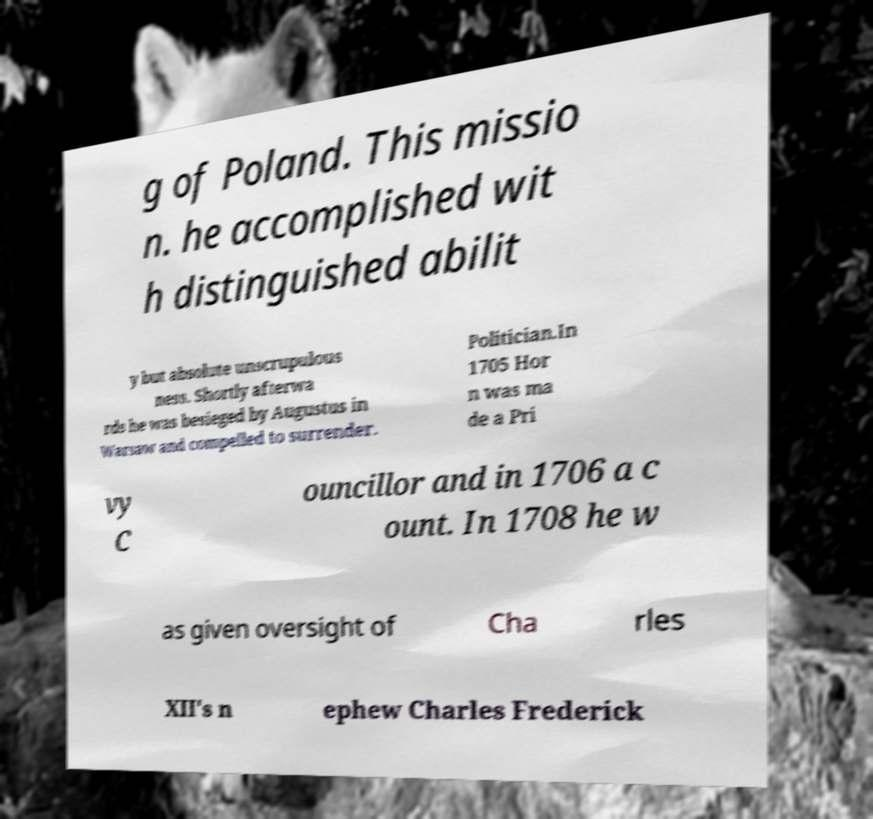Please identify and transcribe the text found in this image. g of Poland. This missio n. he accomplished wit h distinguished abilit y but absolute unscrupulous ness. Shortly afterwa rds he was besieged by Augustus in Warsaw and compelled to surrender. Politician.In 1705 Hor n was ma de a Pri vy C ouncillor and in 1706 a c ount. In 1708 he w as given oversight of Cha rles XII's n ephew Charles Frederick 